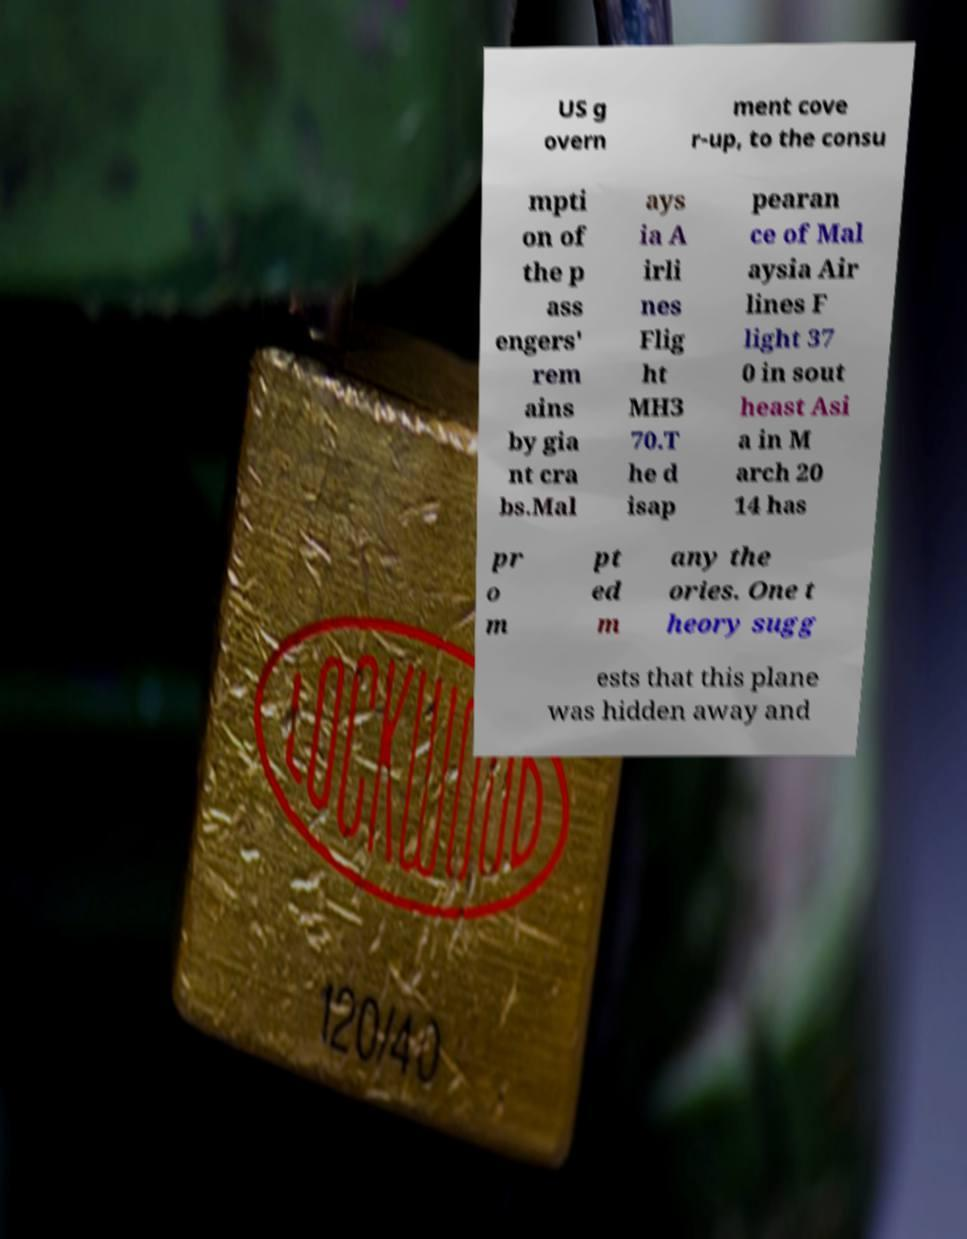There's text embedded in this image that I need extracted. Can you transcribe it verbatim? US g overn ment cove r-up, to the consu mpti on of the p ass engers' rem ains by gia nt cra bs.Mal ays ia A irli nes Flig ht MH3 70.T he d isap pearan ce of Mal aysia Air lines F light 37 0 in sout heast Asi a in M arch 20 14 has pr o m pt ed m any the ories. One t heory sugg ests that this plane was hidden away and 